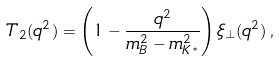Convert formula to latex. <formula><loc_0><loc_0><loc_500><loc_500>T _ { 2 } ( q ^ { 2 } ) = \left ( 1 - \frac { q ^ { 2 } } { m _ { B } ^ { 2 } - m _ { K ^ { * } } ^ { 2 } } \right ) \xi _ { \perp } ( q ^ { 2 } ) \, ,</formula> 